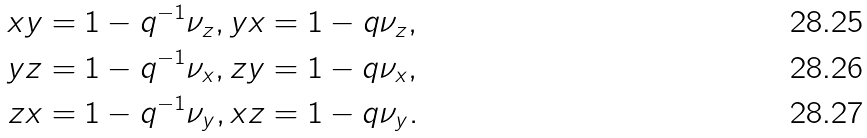<formula> <loc_0><loc_0><loc_500><loc_500>x y & = 1 - q ^ { - 1 } \nu _ { z } , y x = 1 - q \nu _ { z } , \\ y z & = 1 - q ^ { - 1 } \nu _ { x } , z y = 1 - q \nu _ { x } , \\ z x & = 1 - q ^ { - 1 } \nu _ { y } , x z = 1 - q \nu _ { y } .</formula> 